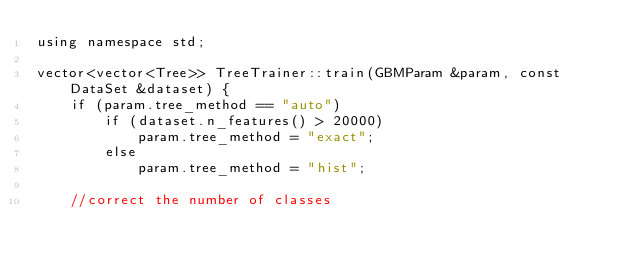Convert code to text. <code><loc_0><loc_0><loc_500><loc_500><_Cuda_>using namespace std;

vector<vector<Tree>> TreeTrainer::train(GBMParam &param, const DataSet &dataset) {
    if (param.tree_method == "auto")
        if (dataset.n_features() > 20000)
            param.tree_method = "exact";
        else
            param.tree_method = "hist";

    //correct the number of classes</code> 